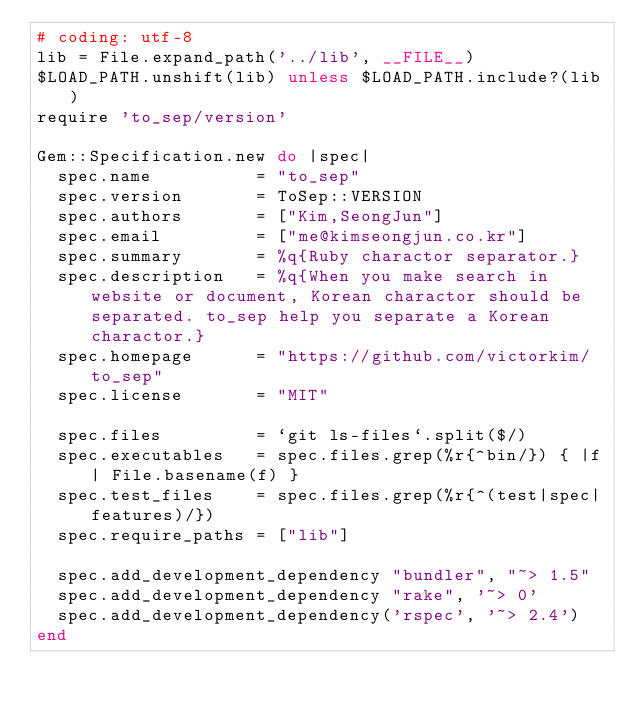<code> <loc_0><loc_0><loc_500><loc_500><_Ruby_># coding: utf-8
lib = File.expand_path('../lib', __FILE__)
$LOAD_PATH.unshift(lib) unless $LOAD_PATH.include?(lib)
require 'to_sep/version'

Gem::Specification.new do |spec|
  spec.name          = "to_sep"
  spec.version       = ToSep::VERSION
  spec.authors       = ["Kim,SeongJun"]
  spec.email         = ["me@kimseongjun.co.kr"]
  spec.summary       = %q{Ruby charactor separator.}
  spec.description   = %q{When you make search in website or document, Korean charactor should be separated. to_sep help you separate a Korean charactor.}
  spec.homepage      = "https://github.com/victorkim/to_sep"
  spec.license       = "MIT"

  spec.files         = `git ls-files`.split($/)
  spec.executables   = spec.files.grep(%r{^bin/}) { |f| File.basename(f) }
  spec.test_files    = spec.files.grep(%r{^(test|spec|features)/})
  spec.require_paths = ["lib"]

  spec.add_development_dependency "bundler", "~> 1.5"
  spec.add_development_dependency "rake", '~> 0'
  spec.add_development_dependency('rspec', '~> 2.4')  
end
</code> 